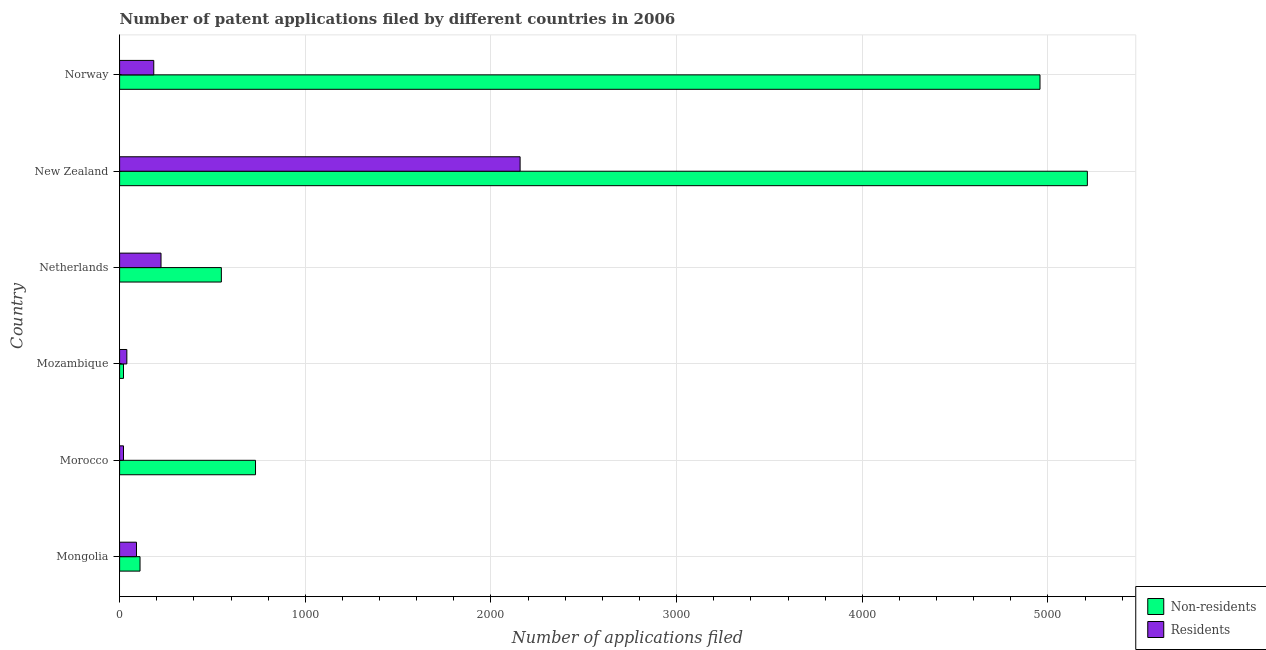How many different coloured bars are there?
Offer a very short reply. 2. How many groups of bars are there?
Offer a terse response. 6. How many bars are there on the 2nd tick from the top?
Provide a short and direct response. 2. How many bars are there on the 1st tick from the bottom?
Offer a very short reply. 2. What is the label of the 5th group of bars from the top?
Give a very brief answer. Morocco. What is the number of patent applications by residents in New Zealand?
Your answer should be compact. 2157. Across all countries, what is the maximum number of patent applications by non residents?
Your answer should be compact. 5212. Across all countries, what is the minimum number of patent applications by residents?
Give a very brief answer. 21. In which country was the number of patent applications by residents maximum?
Ensure brevity in your answer.  New Zealand. In which country was the number of patent applications by residents minimum?
Your answer should be very brief. Morocco. What is the total number of patent applications by non residents in the graph?
Keep it short and to the point. 1.16e+04. What is the difference between the number of patent applications by non residents in Morocco and that in Mozambique?
Make the answer very short. 711. What is the difference between the number of patent applications by non residents in Mozambique and the number of patent applications by residents in New Zealand?
Your answer should be very brief. -2136. What is the average number of patent applications by non residents per country?
Provide a short and direct response. 1930. What is the difference between the number of patent applications by residents and number of patent applications by non residents in Mozambique?
Your response must be concise. 18. What is the ratio of the number of patent applications by non residents in Mongolia to that in Morocco?
Make the answer very short. 0.15. What is the difference between the highest and the second highest number of patent applications by non residents?
Offer a very short reply. 255. What is the difference between the highest and the lowest number of patent applications by non residents?
Your answer should be very brief. 5191. In how many countries, is the number of patent applications by non residents greater than the average number of patent applications by non residents taken over all countries?
Offer a terse response. 2. Is the sum of the number of patent applications by residents in Mozambique and Netherlands greater than the maximum number of patent applications by non residents across all countries?
Give a very brief answer. No. What does the 1st bar from the top in New Zealand represents?
Your response must be concise. Residents. What does the 1st bar from the bottom in Mongolia represents?
Your answer should be compact. Non-residents. How many bars are there?
Ensure brevity in your answer.  12. Are all the bars in the graph horizontal?
Your answer should be compact. Yes. How many countries are there in the graph?
Offer a very short reply. 6. Does the graph contain any zero values?
Make the answer very short. No. How are the legend labels stacked?
Provide a short and direct response. Vertical. What is the title of the graph?
Ensure brevity in your answer.  Number of patent applications filed by different countries in 2006. Does "Domestic liabilities" appear as one of the legend labels in the graph?
Make the answer very short. No. What is the label or title of the X-axis?
Your answer should be very brief. Number of applications filed. What is the label or title of the Y-axis?
Your response must be concise. Country. What is the Number of applications filed of Non-residents in Mongolia?
Provide a succinct answer. 110. What is the Number of applications filed of Residents in Mongolia?
Your answer should be very brief. 91. What is the Number of applications filed of Non-residents in Morocco?
Offer a very short reply. 732. What is the Number of applications filed in Residents in Morocco?
Provide a short and direct response. 21. What is the Number of applications filed in Residents in Mozambique?
Give a very brief answer. 39. What is the Number of applications filed in Non-residents in Netherlands?
Make the answer very short. 548. What is the Number of applications filed in Residents in Netherlands?
Make the answer very short. 223. What is the Number of applications filed of Non-residents in New Zealand?
Offer a very short reply. 5212. What is the Number of applications filed in Residents in New Zealand?
Keep it short and to the point. 2157. What is the Number of applications filed of Non-residents in Norway?
Make the answer very short. 4957. What is the Number of applications filed of Residents in Norway?
Provide a succinct answer. 184. Across all countries, what is the maximum Number of applications filed in Non-residents?
Provide a short and direct response. 5212. Across all countries, what is the maximum Number of applications filed of Residents?
Keep it short and to the point. 2157. Across all countries, what is the minimum Number of applications filed in Non-residents?
Your answer should be very brief. 21. Across all countries, what is the minimum Number of applications filed in Residents?
Your answer should be compact. 21. What is the total Number of applications filed in Non-residents in the graph?
Provide a succinct answer. 1.16e+04. What is the total Number of applications filed of Residents in the graph?
Provide a short and direct response. 2715. What is the difference between the Number of applications filed in Non-residents in Mongolia and that in Morocco?
Offer a terse response. -622. What is the difference between the Number of applications filed of Residents in Mongolia and that in Morocco?
Give a very brief answer. 70. What is the difference between the Number of applications filed of Non-residents in Mongolia and that in Mozambique?
Offer a very short reply. 89. What is the difference between the Number of applications filed of Residents in Mongolia and that in Mozambique?
Keep it short and to the point. 52. What is the difference between the Number of applications filed in Non-residents in Mongolia and that in Netherlands?
Your answer should be very brief. -438. What is the difference between the Number of applications filed in Residents in Mongolia and that in Netherlands?
Ensure brevity in your answer.  -132. What is the difference between the Number of applications filed in Non-residents in Mongolia and that in New Zealand?
Offer a very short reply. -5102. What is the difference between the Number of applications filed in Residents in Mongolia and that in New Zealand?
Your answer should be compact. -2066. What is the difference between the Number of applications filed in Non-residents in Mongolia and that in Norway?
Offer a very short reply. -4847. What is the difference between the Number of applications filed in Residents in Mongolia and that in Norway?
Keep it short and to the point. -93. What is the difference between the Number of applications filed in Non-residents in Morocco and that in Mozambique?
Offer a very short reply. 711. What is the difference between the Number of applications filed in Residents in Morocco and that in Mozambique?
Keep it short and to the point. -18. What is the difference between the Number of applications filed of Non-residents in Morocco and that in Netherlands?
Your response must be concise. 184. What is the difference between the Number of applications filed of Residents in Morocco and that in Netherlands?
Provide a short and direct response. -202. What is the difference between the Number of applications filed of Non-residents in Morocco and that in New Zealand?
Make the answer very short. -4480. What is the difference between the Number of applications filed in Residents in Morocco and that in New Zealand?
Provide a short and direct response. -2136. What is the difference between the Number of applications filed of Non-residents in Morocco and that in Norway?
Make the answer very short. -4225. What is the difference between the Number of applications filed of Residents in Morocco and that in Norway?
Make the answer very short. -163. What is the difference between the Number of applications filed of Non-residents in Mozambique and that in Netherlands?
Make the answer very short. -527. What is the difference between the Number of applications filed of Residents in Mozambique and that in Netherlands?
Ensure brevity in your answer.  -184. What is the difference between the Number of applications filed in Non-residents in Mozambique and that in New Zealand?
Ensure brevity in your answer.  -5191. What is the difference between the Number of applications filed in Residents in Mozambique and that in New Zealand?
Offer a very short reply. -2118. What is the difference between the Number of applications filed of Non-residents in Mozambique and that in Norway?
Provide a short and direct response. -4936. What is the difference between the Number of applications filed of Residents in Mozambique and that in Norway?
Keep it short and to the point. -145. What is the difference between the Number of applications filed in Non-residents in Netherlands and that in New Zealand?
Make the answer very short. -4664. What is the difference between the Number of applications filed in Residents in Netherlands and that in New Zealand?
Make the answer very short. -1934. What is the difference between the Number of applications filed of Non-residents in Netherlands and that in Norway?
Provide a short and direct response. -4409. What is the difference between the Number of applications filed in Residents in Netherlands and that in Norway?
Ensure brevity in your answer.  39. What is the difference between the Number of applications filed of Non-residents in New Zealand and that in Norway?
Offer a very short reply. 255. What is the difference between the Number of applications filed of Residents in New Zealand and that in Norway?
Your answer should be compact. 1973. What is the difference between the Number of applications filed in Non-residents in Mongolia and the Number of applications filed in Residents in Morocco?
Ensure brevity in your answer.  89. What is the difference between the Number of applications filed of Non-residents in Mongolia and the Number of applications filed of Residents in Netherlands?
Keep it short and to the point. -113. What is the difference between the Number of applications filed in Non-residents in Mongolia and the Number of applications filed in Residents in New Zealand?
Ensure brevity in your answer.  -2047. What is the difference between the Number of applications filed of Non-residents in Mongolia and the Number of applications filed of Residents in Norway?
Make the answer very short. -74. What is the difference between the Number of applications filed of Non-residents in Morocco and the Number of applications filed of Residents in Mozambique?
Keep it short and to the point. 693. What is the difference between the Number of applications filed in Non-residents in Morocco and the Number of applications filed in Residents in Netherlands?
Make the answer very short. 509. What is the difference between the Number of applications filed of Non-residents in Morocco and the Number of applications filed of Residents in New Zealand?
Keep it short and to the point. -1425. What is the difference between the Number of applications filed in Non-residents in Morocco and the Number of applications filed in Residents in Norway?
Make the answer very short. 548. What is the difference between the Number of applications filed in Non-residents in Mozambique and the Number of applications filed in Residents in Netherlands?
Make the answer very short. -202. What is the difference between the Number of applications filed in Non-residents in Mozambique and the Number of applications filed in Residents in New Zealand?
Your answer should be very brief. -2136. What is the difference between the Number of applications filed of Non-residents in Mozambique and the Number of applications filed of Residents in Norway?
Ensure brevity in your answer.  -163. What is the difference between the Number of applications filed of Non-residents in Netherlands and the Number of applications filed of Residents in New Zealand?
Provide a succinct answer. -1609. What is the difference between the Number of applications filed in Non-residents in Netherlands and the Number of applications filed in Residents in Norway?
Provide a short and direct response. 364. What is the difference between the Number of applications filed in Non-residents in New Zealand and the Number of applications filed in Residents in Norway?
Provide a succinct answer. 5028. What is the average Number of applications filed in Non-residents per country?
Provide a succinct answer. 1930. What is the average Number of applications filed in Residents per country?
Provide a succinct answer. 452.5. What is the difference between the Number of applications filed of Non-residents and Number of applications filed of Residents in Mongolia?
Provide a short and direct response. 19. What is the difference between the Number of applications filed in Non-residents and Number of applications filed in Residents in Morocco?
Ensure brevity in your answer.  711. What is the difference between the Number of applications filed of Non-residents and Number of applications filed of Residents in Netherlands?
Make the answer very short. 325. What is the difference between the Number of applications filed in Non-residents and Number of applications filed in Residents in New Zealand?
Your answer should be compact. 3055. What is the difference between the Number of applications filed of Non-residents and Number of applications filed of Residents in Norway?
Provide a succinct answer. 4773. What is the ratio of the Number of applications filed in Non-residents in Mongolia to that in Morocco?
Your answer should be compact. 0.15. What is the ratio of the Number of applications filed of Residents in Mongolia to that in Morocco?
Give a very brief answer. 4.33. What is the ratio of the Number of applications filed of Non-residents in Mongolia to that in Mozambique?
Provide a succinct answer. 5.24. What is the ratio of the Number of applications filed of Residents in Mongolia to that in Mozambique?
Offer a terse response. 2.33. What is the ratio of the Number of applications filed of Non-residents in Mongolia to that in Netherlands?
Your answer should be very brief. 0.2. What is the ratio of the Number of applications filed of Residents in Mongolia to that in Netherlands?
Give a very brief answer. 0.41. What is the ratio of the Number of applications filed in Non-residents in Mongolia to that in New Zealand?
Provide a succinct answer. 0.02. What is the ratio of the Number of applications filed of Residents in Mongolia to that in New Zealand?
Your response must be concise. 0.04. What is the ratio of the Number of applications filed of Non-residents in Mongolia to that in Norway?
Offer a very short reply. 0.02. What is the ratio of the Number of applications filed in Residents in Mongolia to that in Norway?
Give a very brief answer. 0.49. What is the ratio of the Number of applications filed in Non-residents in Morocco to that in Mozambique?
Keep it short and to the point. 34.86. What is the ratio of the Number of applications filed of Residents in Morocco to that in Mozambique?
Provide a succinct answer. 0.54. What is the ratio of the Number of applications filed in Non-residents in Morocco to that in Netherlands?
Provide a short and direct response. 1.34. What is the ratio of the Number of applications filed of Residents in Morocco to that in Netherlands?
Give a very brief answer. 0.09. What is the ratio of the Number of applications filed in Non-residents in Morocco to that in New Zealand?
Keep it short and to the point. 0.14. What is the ratio of the Number of applications filed in Residents in Morocco to that in New Zealand?
Provide a short and direct response. 0.01. What is the ratio of the Number of applications filed of Non-residents in Morocco to that in Norway?
Ensure brevity in your answer.  0.15. What is the ratio of the Number of applications filed in Residents in Morocco to that in Norway?
Your response must be concise. 0.11. What is the ratio of the Number of applications filed in Non-residents in Mozambique to that in Netherlands?
Ensure brevity in your answer.  0.04. What is the ratio of the Number of applications filed in Residents in Mozambique to that in Netherlands?
Make the answer very short. 0.17. What is the ratio of the Number of applications filed in Non-residents in Mozambique to that in New Zealand?
Your answer should be very brief. 0. What is the ratio of the Number of applications filed in Residents in Mozambique to that in New Zealand?
Offer a very short reply. 0.02. What is the ratio of the Number of applications filed of Non-residents in Mozambique to that in Norway?
Provide a short and direct response. 0. What is the ratio of the Number of applications filed of Residents in Mozambique to that in Norway?
Give a very brief answer. 0.21. What is the ratio of the Number of applications filed in Non-residents in Netherlands to that in New Zealand?
Offer a terse response. 0.11. What is the ratio of the Number of applications filed in Residents in Netherlands to that in New Zealand?
Keep it short and to the point. 0.1. What is the ratio of the Number of applications filed in Non-residents in Netherlands to that in Norway?
Provide a succinct answer. 0.11. What is the ratio of the Number of applications filed of Residents in Netherlands to that in Norway?
Your answer should be compact. 1.21. What is the ratio of the Number of applications filed in Non-residents in New Zealand to that in Norway?
Your answer should be very brief. 1.05. What is the ratio of the Number of applications filed of Residents in New Zealand to that in Norway?
Provide a succinct answer. 11.72. What is the difference between the highest and the second highest Number of applications filed in Non-residents?
Keep it short and to the point. 255. What is the difference between the highest and the second highest Number of applications filed in Residents?
Keep it short and to the point. 1934. What is the difference between the highest and the lowest Number of applications filed of Non-residents?
Make the answer very short. 5191. What is the difference between the highest and the lowest Number of applications filed in Residents?
Your response must be concise. 2136. 